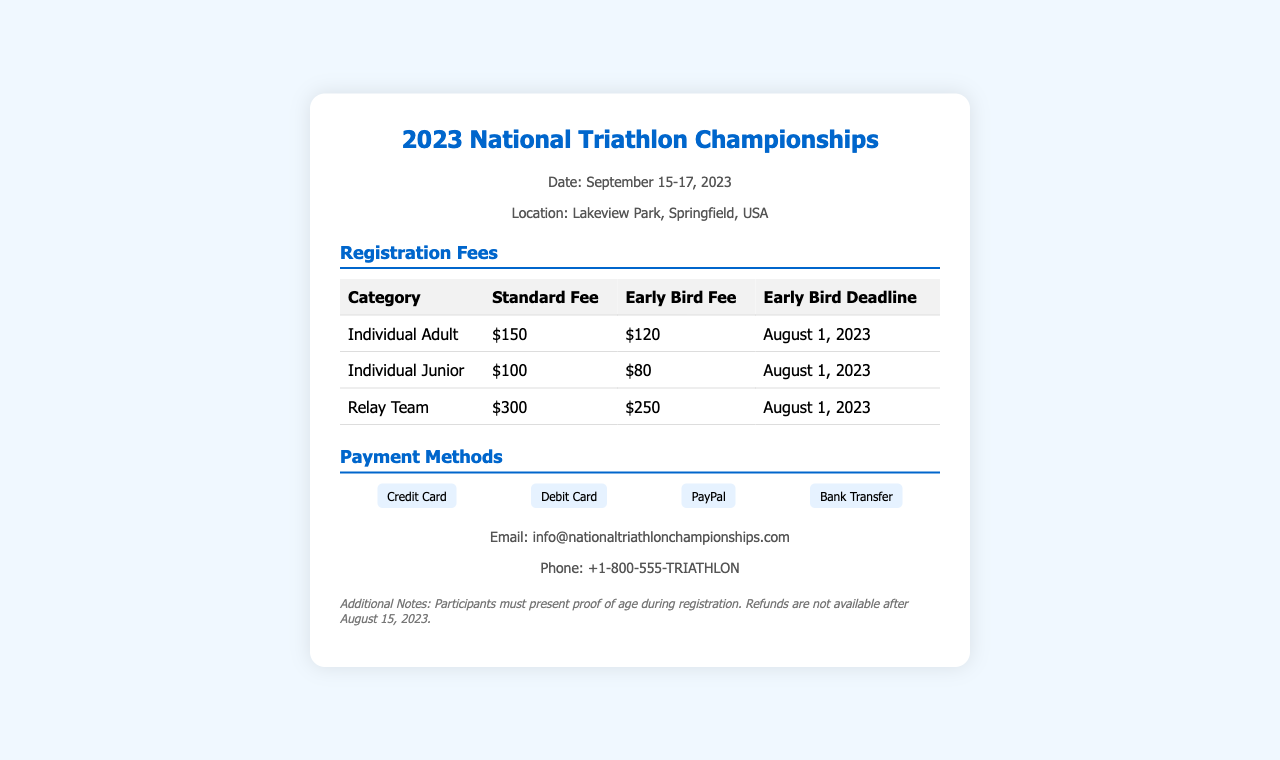What is the date of the event? The date of the event is specified in the document and mentioned as September 15-17, 2023.
Answer: September 15-17, 2023 What is the standard fee for an Individual Junior? The standard fee for an Individual Junior is presented in the fees table under the relevant category.
Answer: $100 What is the early bird fee for Relay Team? The early bird fee for the Relay Team is found in the fees section of the document.
Answer: $250 What are the payment methods available? The payment methods are listed in a section and include various forms of payment.
Answer: Credit Card, Debit Card, PayPal, Bank Transfer What is the early bird deadline for registration? The early bird deadline is indicated in the table within the registration fees section of the document.
Answer: August 1, 2023 Is a refund available after August 15, 2023? The document mentions specific conditions for refunds, indicating that they are not available after a certain date.
Answer: No What must participants present during registration? The document specifies a requirement that participants must meet when registering for the event.
Answer: Proof of age What is the location of the championships? The location of the championships is indicated in the event information section of the document.
Answer: Lakeview Park, Springfield, USA 